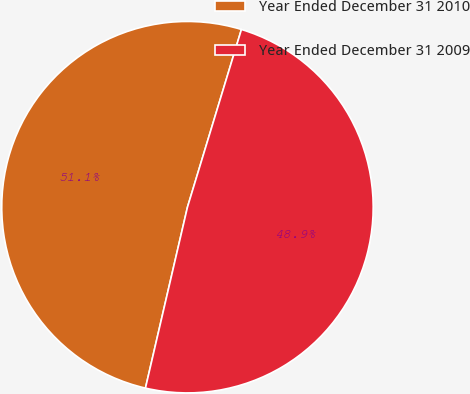Convert chart. <chart><loc_0><loc_0><loc_500><loc_500><pie_chart><fcel>Year Ended December 31 2010<fcel>Year Ended December 31 2009<nl><fcel>51.06%<fcel>48.94%<nl></chart> 